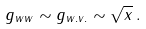<formula> <loc_0><loc_0><loc_500><loc_500>g _ { w w } \sim g _ { w . v . } \sim \sqrt { x } \, .</formula> 